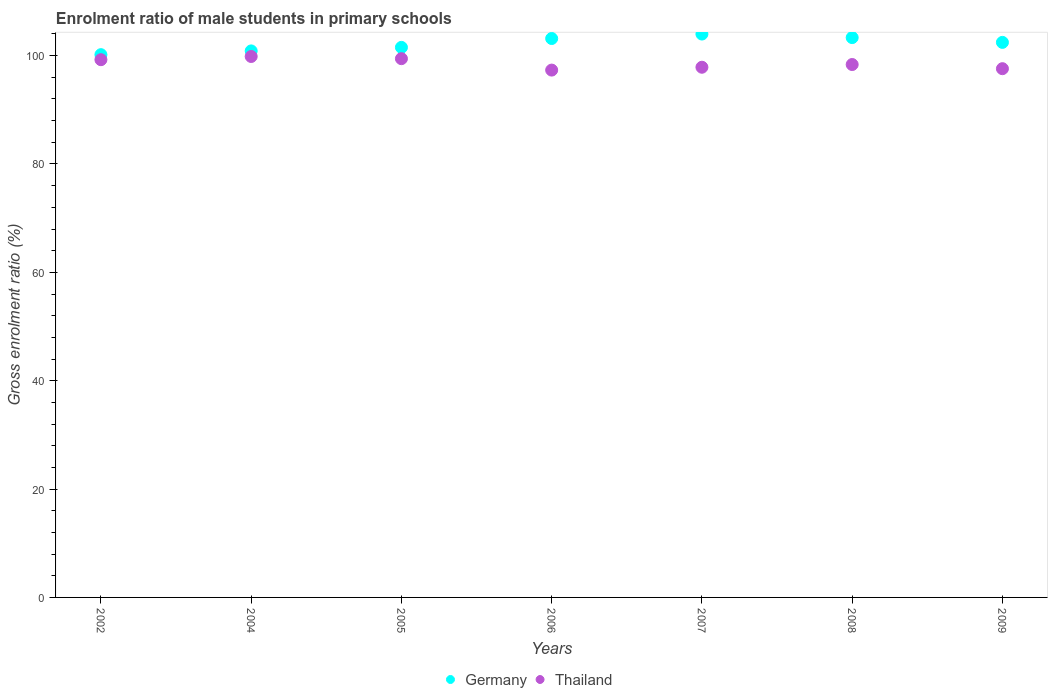How many different coloured dotlines are there?
Offer a very short reply. 2. What is the enrolment ratio of male students in primary schools in Thailand in 2004?
Provide a short and direct response. 99.84. Across all years, what is the maximum enrolment ratio of male students in primary schools in Thailand?
Offer a very short reply. 99.84. Across all years, what is the minimum enrolment ratio of male students in primary schools in Thailand?
Offer a very short reply. 97.33. In which year was the enrolment ratio of male students in primary schools in Germany minimum?
Your response must be concise. 2002. What is the total enrolment ratio of male students in primary schools in Thailand in the graph?
Your answer should be very brief. 689.66. What is the difference between the enrolment ratio of male students in primary schools in Thailand in 2004 and that in 2009?
Your response must be concise. 2.25. What is the difference between the enrolment ratio of male students in primary schools in Thailand in 2006 and the enrolment ratio of male students in primary schools in Germany in 2005?
Your answer should be compact. -4.19. What is the average enrolment ratio of male students in primary schools in Thailand per year?
Offer a very short reply. 98.52. In the year 2009, what is the difference between the enrolment ratio of male students in primary schools in Germany and enrolment ratio of male students in primary schools in Thailand?
Your answer should be compact. 4.86. In how many years, is the enrolment ratio of male students in primary schools in Thailand greater than 68 %?
Your response must be concise. 7. What is the ratio of the enrolment ratio of male students in primary schools in Germany in 2005 to that in 2007?
Your answer should be compact. 0.98. Is the enrolment ratio of male students in primary schools in Thailand in 2007 less than that in 2008?
Your answer should be compact. Yes. What is the difference between the highest and the second highest enrolment ratio of male students in primary schools in Germany?
Provide a short and direct response. 0.65. What is the difference between the highest and the lowest enrolment ratio of male students in primary schools in Thailand?
Offer a very short reply. 2.51. Is the sum of the enrolment ratio of male students in primary schools in Germany in 2006 and 2007 greater than the maximum enrolment ratio of male students in primary schools in Thailand across all years?
Your answer should be compact. Yes. Does the enrolment ratio of male students in primary schools in Germany monotonically increase over the years?
Ensure brevity in your answer.  No. How many dotlines are there?
Your answer should be very brief. 2. Are the values on the major ticks of Y-axis written in scientific E-notation?
Ensure brevity in your answer.  No. Does the graph contain grids?
Make the answer very short. No. How many legend labels are there?
Offer a very short reply. 2. How are the legend labels stacked?
Offer a terse response. Horizontal. What is the title of the graph?
Your response must be concise. Enrolment ratio of male students in primary schools. What is the label or title of the X-axis?
Give a very brief answer. Years. What is the label or title of the Y-axis?
Your response must be concise. Gross enrolment ratio (%). What is the Gross enrolment ratio (%) of Germany in 2002?
Offer a very short reply. 100.18. What is the Gross enrolment ratio (%) in Thailand in 2002?
Give a very brief answer. 99.25. What is the Gross enrolment ratio (%) of Germany in 2004?
Make the answer very short. 100.87. What is the Gross enrolment ratio (%) in Thailand in 2004?
Offer a terse response. 99.84. What is the Gross enrolment ratio (%) of Germany in 2005?
Offer a terse response. 101.52. What is the Gross enrolment ratio (%) of Thailand in 2005?
Your answer should be compact. 99.44. What is the Gross enrolment ratio (%) of Germany in 2006?
Your answer should be compact. 103.16. What is the Gross enrolment ratio (%) in Thailand in 2006?
Give a very brief answer. 97.33. What is the Gross enrolment ratio (%) in Germany in 2007?
Your answer should be very brief. 103.98. What is the Gross enrolment ratio (%) of Thailand in 2007?
Offer a very short reply. 97.86. What is the Gross enrolment ratio (%) in Germany in 2008?
Make the answer very short. 103.33. What is the Gross enrolment ratio (%) in Thailand in 2008?
Keep it short and to the point. 98.36. What is the Gross enrolment ratio (%) in Germany in 2009?
Ensure brevity in your answer.  102.45. What is the Gross enrolment ratio (%) in Thailand in 2009?
Your answer should be very brief. 97.59. Across all years, what is the maximum Gross enrolment ratio (%) in Germany?
Your response must be concise. 103.98. Across all years, what is the maximum Gross enrolment ratio (%) in Thailand?
Your answer should be very brief. 99.84. Across all years, what is the minimum Gross enrolment ratio (%) of Germany?
Your answer should be compact. 100.18. Across all years, what is the minimum Gross enrolment ratio (%) in Thailand?
Offer a terse response. 97.33. What is the total Gross enrolment ratio (%) of Germany in the graph?
Provide a short and direct response. 715.49. What is the total Gross enrolment ratio (%) of Thailand in the graph?
Ensure brevity in your answer.  689.66. What is the difference between the Gross enrolment ratio (%) of Germany in 2002 and that in 2004?
Provide a short and direct response. -0.69. What is the difference between the Gross enrolment ratio (%) of Thailand in 2002 and that in 2004?
Keep it short and to the point. -0.59. What is the difference between the Gross enrolment ratio (%) in Germany in 2002 and that in 2005?
Your answer should be compact. -1.34. What is the difference between the Gross enrolment ratio (%) of Thailand in 2002 and that in 2005?
Provide a succinct answer. -0.19. What is the difference between the Gross enrolment ratio (%) of Germany in 2002 and that in 2006?
Your response must be concise. -2.98. What is the difference between the Gross enrolment ratio (%) in Thailand in 2002 and that in 2006?
Keep it short and to the point. 1.92. What is the difference between the Gross enrolment ratio (%) of Germany in 2002 and that in 2007?
Your answer should be compact. -3.8. What is the difference between the Gross enrolment ratio (%) in Thailand in 2002 and that in 2007?
Your answer should be very brief. 1.39. What is the difference between the Gross enrolment ratio (%) of Germany in 2002 and that in 2008?
Your response must be concise. -3.15. What is the difference between the Gross enrolment ratio (%) of Thailand in 2002 and that in 2008?
Give a very brief answer. 0.89. What is the difference between the Gross enrolment ratio (%) of Germany in 2002 and that in 2009?
Your response must be concise. -2.27. What is the difference between the Gross enrolment ratio (%) in Thailand in 2002 and that in 2009?
Ensure brevity in your answer.  1.66. What is the difference between the Gross enrolment ratio (%) in Germany in 2004 and that in 2005?
Your response must be concise. -0.65. What is the difference between the Gross enrolment ratio (%) of Thailand in 2004 and that in 2005?
Ensure brevity in your answer.  0.4. What is the difference between the Gross enrolment ratio (%) in Germany in 2004 and that in 2006?
Your response must be concise. -2.29. What is the difference between the Gross enrolment ratio (%) in Thailand in 2004 and that in 2006?
Offer a terse response. 2.51. What is the difference between the Gross enrolment ratio (%) in Germany in 2004 and that in 2007?
Keep it short and to the point. -3.11. What is the difference between the Gross enrolment ratio (%) of Thailand in 2004 and that in 2007?
Offer a very short reply. 1.99. What is the difference between the Gross enrolment ratio (%) of Germany in 2004 and that in 2008?
Your response must be concise. -2.46. What is the difference between the Gross enrolment ratio (%) of Thailand in 2004 and that in 2008?
Keep it short and to the point. 1.48. What is the difference between the Gross enrolment ratio (%) in Germany in 2004 and that in 2009?
Ensure brevity in your answer.  -1.57. What is the difference between the Gross enrolment ratio (%) of Thailand in 2004 and that in 2009?
Give a very brief answer. 2.25. What is the difference between the Gross enrolment ratio (%) of Germany in 2005 and that in 2006?
Offer a very short reply. -1.64. What is the difference between the Gross enrolment ratio (%) in Thailand in 2005 and that in 2006?
Your answer should be very brief. 2.11. What is the difference between the Gross enrolment ratio (%) in Germany in 2005 and that in 2007?
Offer a very short reply. -2.46. What is the difference between the Gross enrolment ratio (%) of Thailand in 2005 and that in 2007?
Your answer should be compact. 1.58. What is the difference between the Gross enrolment ratio (%) in Germany in 2005 and that in 2008?
Offer a terse response. -1.81. What is the difference between the Gross enrolment ratio (%) of Thailand in 2005 and that in 2008?
Ensure brevity in your answer.  1.08. What is the difference between the Gross enrolment ratio (%) in Germany in 2005 and that in 2009?
Offer a very short reply. -0.92. What is the difference between the Gross enrolment ratio (%) of Thailand in 2005 and that in 2009?
Give a very brief answer. 1.85. What is the difference between the Gross enrolment ratio (%) of Germany in 2006 and that in 2007?
Offer a very short reply. -0.82. What is the difference between the Gross enrolment ratio (%) of Thailand in 2006 and that in 2007?
Give a very brief answer. -0.53. What is the difference between the Gross enrolment ratio (%) of Germany in 2006 and that in 2008?
Your response must be concise. -0.17. What is the difference between the Gross enrolment ratio (%) of Thailand in 2006 and that in 2008?
Provide a succinct answer. -1.03. What is the difference between the Gross enrolment ratio (%) in Germany in 2006 and that in 2009?
Your answer should be very brief. 0.71. What is the difference between the Gross enrolment ratio (%) in Thailand in 2006 and that in 2009?
Provide a short and direct response. -0.26. What is the difference between the Gross enrolment ratio (%) in Germany in 2007 and that in 2008?
Make the answer very short. 0.65. What is the difference between the Gross enrolment ratio (%) of Thailand in 2007 and that in 2008?
Provide a succinct answer. -0.5. What is the difference between the Gross enrolment ratio (%) of Germany in 2007 and that in 2009?
Provide a short and direct response. 1.54. What is the difference between the Gross enrolment ratio (%) in Thailand in 2007 and that in 2009?
Your answer should be very brief. 0.27. What is the difference between the Gross enrolment ratio (%) of Germany in 2008 and that in 2009?
Keep it short and to the point. 0.88. What is the difference between the Gross enrolment ratio (%) in Thailand in 2008 and that in 2009?
Your answer should be compact. 0.77. What is the difference between the Gross enrolment ratio (%) of Germany in 2002 and the Gross enrolment ratio (%) of Thailand in 2004?
Your answer should be compact. 0.34. What is the difference between the Gross enrolment ratio (%) of Germany in 2002 and the Gross enrolment ratio (%) of Thailand in 2005?
Provide a short and direct response. 0.74. What is the difference between the Gross enrolment ratio (%) in Germany in 2002 and the Gross enrolment ratio (%) in Thailand in 2006?
Offer a very short reply. 2.85. What is the difference between the Gross enrolment ratio (%) in Germany in 2002 and the Gross enrolment ratio (%) in Thailand in 2007?
Offer a very short reply. 2.32. What is the difference between the Gross enrolment ratio (%) of Germany in 2002 and the Gross enrolment ratio (%) of Thailand in 2008?
Provide a short and direct response. 1.82. What is the difference between the Gross enrolment ratio (%) in Germany in 2002 and the Gross enrolment ratio (%) in Thailand in 2009?
Provide a succinct answer. 2.59. What is the difference between the Gross enrolment ratio (%) of Germany in 2004 and the Gross enrolment ratio (%) of Thailand in 2005?
Offer a terse response. 1.43. What is the difference between the Gross enrolment ratio (%) in Germany in 2004 and the Gross enrolment ratio (%) in Thailand in 2006?
Ensure brevity in your answer.  3.54. What is the difference between the Gross enrolment ratio (%) of Germany in 2004 and the Gross enrolment ratio (%) of Thailand in 2007?
Offer a terse response. 3.01. What is the difference between the Gross enrolment ratio (%) of Germany in 2004 and the Gross enrolment ratio (%) of Thailand in 2008?
Ensure brevity in your answer.  2.51. What is the difference between the Gross enrolment ratio (%) of Germany in 2004 and the Gross enrolment ratio (%) of Thailand in 2009?
Provide a succinct answer. 3.28. What is the difference between the Gross enrolment ratio (%) in Germany in 2005 and the Gross enrolment ratio (%) in Thailand in 2006?
Provide a succinct answer. 4.19. What is the difference between the Gross enrolment ratio (%) in Germany in 2005 and the Gross enrolment ratio (%) in Thailand in 2007?
Ensure brevity in your answer.  3.67. What is the difference between the Gross enrolment ratio (%) in Germany in 2005 and the Gross enrolment ratio (%) in Thailand in 2008?
Offer a terse response. 3.16. What is the difference between the Gross enrolment ratio (%) in Germany in 2005 and the Gross enrolment ratio (%) in Thailand in 2009?
Your answer should be very brief. 3.93. What is the difference between the Gross enrolment ratio (%) of Germany in 2006 and the Gross enrolment ratio (%) of Thailand in 2007?
Provide a short and direct response. 5.3. What is the difference between the Gross enrolment ratio (%) in Germany in 2006 and the Gross enrolment ratio (%) in Thailand in 2008?
Offer a terse response. 4.8. What is the difference between the Gross enrolment ratio (%) of Germany in 2006 and the Gross enrolment ratio (%) of Thailand in 2009?
Your answer should be very brief. 5.57. What is the difference between the Gross enrolment ratio (%) of Germany in 2007 and the Gross enrolment ratio (%) of Thailand in 2008?
Your answer should be compact. 5.62. What is the difference between the Gross enrolment ratio (%) of Germany in 2007 and the Gross enrolment ratio (%) of Thailand in 2009?
Your answer should be compact. 6.39. What is the difference between the Gross enrolment ratio (%) in Germany in 2008 and the Gross enrolment ratio (%) in Thailand in 2009?
Your response must be concise. 5.74. What is the average Gross enrolment ratio (%) in Germany per year?
Your answer should be very brief. 102.21. What is the average Gross enrolment ratio (%) of Thailand per year?
Give a very brief answer. 98.52. In the year 2002, what is the difference between the Gross enrolment ratio (%) in Germany and Gross enrolment ratio (%) in Thailand?
Keep it short and to the point. 0.93. In the year 2004, what is the difference between the Gross enrolment ratio (%) in Germany and Gross enrolment ratio (%) in Thailand?
Give a very brief answer. 1.03. In the year 2005, what is the difference between the Gross enrolment ratio (%) in Germany and Gross enrolment ratio (%) in Thailand?
Your answer should be compact. 2.08. In the year 2006, what is the difference between the Gross enrolment ratio (%) in Germany and Gross enrolment ratio (%) in Thailand?
Ensure brevity in your answer.  5.83. In the year 2007, what is the difference between the Gross enrolment ratio (%) in Germany and Gross enrolment ratio (%) in Thailand?
Your answer should be very brief. 6.13. In the year 2008, what is the difference between the Gross enrolment ratio (%) of Germany and Gross enrolment ratio (%) of Thailand?
Offer a very short reply. 4.97. In the year 2009, what is the difference between the Gross enrolment ratio (%) of Germany and Gross enrolment ratio (%) of Thailand?
Make the answer very short. 4.86. What is the ratio of the Gross enrolment ratio (%) of Germany in 2002 to that in 2004?
Offer a terse response. 0.99. What is the ratio of the Gross enrolment ratio (%) in Thailand in 2002 to that in 2004?
Give a very brief answer. 0.99. What is the ratio of the Gross enrolment ratio (%) in Germany in 2002 to that in 2005?
Keep it short and to the point. 0.99. What is the ratio of the Gross enrolment ratio (%) in Germany in 2002 to that in 2006?
Provide a short and direct response. 0.97. What is the ratio of the Gross enrolment ratio (%) of Thailand in 2002 to that in 2006?
Make the answer very short. 1.02. What is the ratio of the Gross enrolment ratio (%) in Germany in 2002 to that in 2007?
Provide a short and direct response. 0.96. What is the ratio of the Gross enrolment ratio (%) of Thailand in 2002 to that in 2007?
Your answer should be compact. 1.01. What is the ratio of the Gross enrolment ratio (%) in Germany in 2002 to that in 2008?
Provide a short and direct response. 0.97. What is the ratio of the Gross enrolment ratio (%) of Thailand in 2002 to that in 2008?
Give a very brief answer. 1.01. What is the ratio of the Gross enrolment ratio (%) of Germany in 2002 to that in 2009?
Your answer should be compact. 0.98. What is the ratio of the Gross enrolment ratio (%) of Germany in 2004 to that in 2005?
Provide a succinct answer. 0.99. What is the ratio of the Gross enrolment ratio (%) in Germany in 2004 to that in 2006?
Offer a terse response. 0.98. What is the ratio of the Gross enrolment ratio (%) in Thailand in 2004 to that in 2006?
Make the answer very short. 1.03. What is the ratio of the Gross enrolment ratio (%) in Germany in 2004 to that in 2007?
Keep it short and to the point. 0.97. What is the ratio of the Gross enrolment ratio (%) of Thailand in 2004 to that in 2007?
Keep it short and to the point. 1.02. What is the ratio of the Gross enrolment ratio (%) of Germany in 2004 to that in 2008?
Your answer should be compact. 0.98. What is the ratio of the Gross enrolment ratio (%) in Thailand in 2004 to that in 2008?
Provide a succinct answer. 1.02. What is the ratio of the Gross enrolment ratio (%) of Germany in 2004 to that in 2009?
Your answer should be very brief. 0.98. What is the ratio of the Gross enrolment ratio (%) of Thailand in 2004 to that in 2009?
Your answer should be very brief. 1.02. What is the ratio of the Gross enrolment ratio (%) of Germany in 2005 to that in 2006?
Give a very brief answer. 0.98. What is the ratio of the Gross enrolment ratio (%) in Thailand in 2005 to that in 2006?
Offer a terse response. 1.02. What is the ratio of the Gross enrolment ratio (%) in Germany in 2005 to that in 2007?
Offer a terse response. 0.98. What is the ratio of the Gross enrolment ratio (%) of Thailand in 2005 to that in 2007?
Ensure brevity in your answer.  1.02. What is the ratio of the Gross enrolment ratio (%) in Germany in 2005 to that in 2008?
Your response must be concise. 0.98. What is the ratio of the Gross enrolment ratio (%) in Thailand in 2005 to that in 2008?
Make the answer very short. 1.01. What is the ratio of the Gross enrolment ratio (%) of Thailand in 2005 to that in 2009?
Provide a succinct answer. 1.02. What is the ratio of the Gross enrolment ratio (%) in Germany in 2006 to that in 2008?
Offer a terse response. 1. What is the ratio of the Gross enrolment ratio (%) of Thailand in 2006 to that in 2008?
Keep it short and to the point. 0.99. What is the ratio of the Gross enrolment ratio (%) in Germany in 2006 to that in 2009?
Offer a terse response. 1.01. What is the ratio of the Gross enrolment ratio (%) of Thailand in 2006 to that in 2009?
Your answer should be very brief. 1. What is the ratio of the Gross enrolment ratio (%) of Germany in 2007 to that in 2008?
Ensure brevity in your answer.  1.01. What is the ratio of the Gross enrolment ratio (%) in Thailand in 2007 to that in 2008?
Keep it short and to the point. 0.99. What is the ratio of the Gross enrolment ratio (%) in Germany in 2007 to that in 2009?
Ensure brevity in your answer.  1.01. What is the ratio of the Gross enrolment ratio (%) in Thailand in 2007 to that in 2009?
Your answer should be compact. 1. What is the ratio of the Gross enrolment ratio (%) of Germany in 2008 to that in 2009?
Your answer should be very brief. 1.01. What is the ratio of the Gross enrolment ratio (%) of Thailand in 2008 to that in 2009?
Ensure brevity in your answer.  1.01. What is the difference between the highest and the second highest Gross enrolment ratio (%) in Germany?
Your answer should be very brief. 0.65. What is the difference between the highest and the second highest Gross enrolment ratio (%) of Thailand?
Give a very brief answer. 0.4. What is the difference between the highest and the lowest Gross enrolment ratio (%) of Germany?
Make the answer very short. 3.8. What is the difference between the highest and the lowest Gross enrolment ratio (%) of Thailand?
Provide a succinct answer. 2.51. 